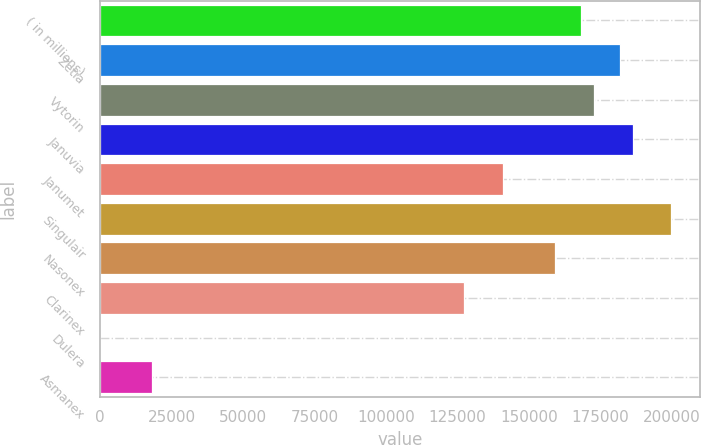Convert chart. <chart><loc_0><loc_0><loc_500><loc_500><bar_chart><fcel>( in millions)<fcel>Zetia<fcel>Vytorin<fcel>Januvia<fcel>Janumet<fcel>Singulair<fcel>Nasonex<fcel>Clarinex<fcel>Dulera<fcel>Asmanex<nl><fcel>168055<fcel>181680<fcel>172596<fcel>186222<fcel>140804<fcel>199847<fcel>158971<fcel>127178<fcel>8<fcel>18175.2<nl></chart> 